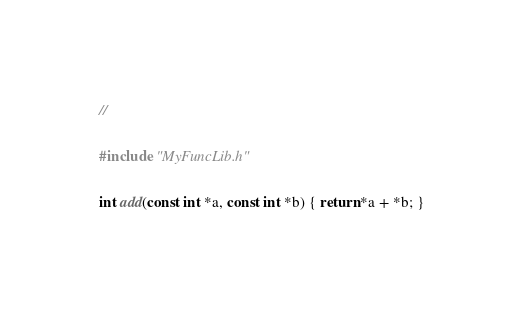<code> <loc_0><loc_0><loc_500><loc_500><_C_>//

#include "MyFuncLib.h"

int add(const int *a, const int *b) { return *a + *b; }
</code> 